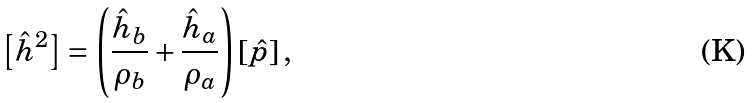<formula> <loc_0><loc_0><loc_500><loc_500>\left [ \hat { h } ^ { 2 } \right ] = \left ( \frac { \hat { h } _ { b } } { \rho _ { b } } + \frac { \hat { h } _ { a } } { \rho _ { a } } \right ) \left [ \hat { p } \right ] ,</formula> 